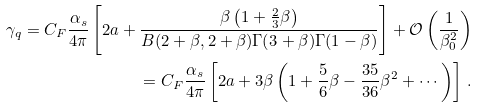Convert formula to latex. <formula><loc_0><loc_0><loc_500><loc_500>\gamma _ { q } = C _ { F } \frac { \alpha _ { s } } { 4 \pi } \left [ 2 a + \frac { \beta \left ( 1 + \frac { 2 } { 3 } \beta \right ) } { B ( 2 + \beta , 2 + \beta ) \Gamma ( 3 + \beta ) \Gamma ( 1 - \beta ) } \right ] + \mathcal { O } \left ( \frac { 1 } { \beta _ { 0 } ^ { 2 } } \right ) \\ = C _ { F } \frac { \alpha _ { s } } { 4 \pi } \left [ 2 a + 3 \beta \left ( 1 + \frac { 5 } { 6 } \beta - \frac { 3 5 } { 3 6 } \beta ^ { 2 } + \cdots \right ) \right ] \, .</formula> 